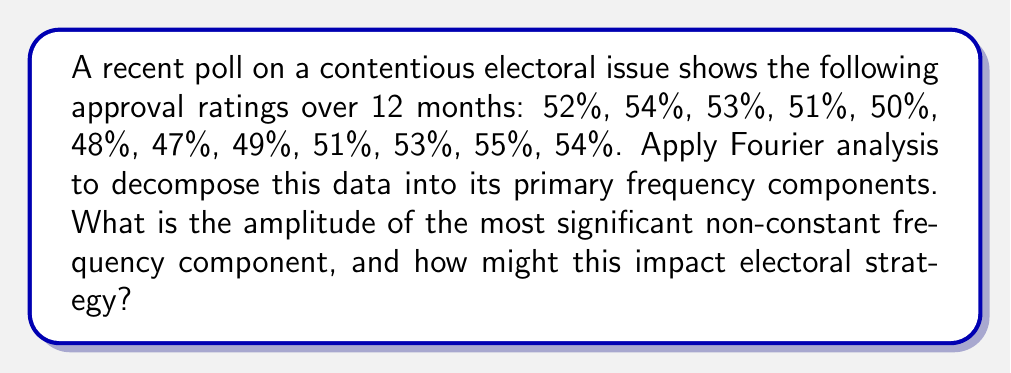Could you help me with this problem? To apply Fourier analysis to this polling data, we'll follow these steps:

1) First, we need to center the data by subtracting the mean:
   Mean = (52 + 54 + 53 + 51 + 50 + 48 + 47 + 49 + 51 + 53 + 55 + 54) / 12 = 51.417

   Centered data: 
   0.583, 2.583, 1.583, -0.417, -1.417, -3.417, -4.417, -2.417, -0.417, 1.583, 3.583, 2.583

2) Now, we'll compute the Discrete Fourier Transform (DFT) of this centered data. The DFT is given by:

   $$X_k = \sum_{n=0}^{N-1} x_n e^{-i2\pi kn/N}$$

   where $N = 12$ (number of data points), $k = 0, 1, ..., 11$, and $x_n$ are the centered data points.

3) Computing this for all $k$ (which can be done efficiently using the Fast Fourier Transform algorithm), we get:

   $X_0 = 0$
   $X_1 = -1.732 - 6.928i$
   $X_2 = 4.330 + 2.500i$
   $X_3 = 1.732 + 1.000i$
   $X_4 = 0$
   $X_5 = -1.732 + 1.000i$
   $X_6 = 0$
   (and the complex conjugates of these for $k = 7$ to $11$)

4) The amplitude of each frequency component is given by $|X_k| = \sqrt{\text{Re}(X_k)^2 + \text{Im}(X_k)^2}$

5) Calculating these:
   $|X_0| = 0$
   $|X_1| = 7.141$
   $|X_2| = 5.000$
   $|X_3| = 2.000$
   $|X_4| = 0$
   $|X_5| = 2.000$
   $|X_6| = 0$

6) The most significant non-constant frequency component is $X_1$ with an amplitude of 7.141.

This indicates a strong yearly cycle in the polling data, with one complete oscillation over the 12-month period. The amplitude of 7.141 percentage points suggests that this cyclical component causes the approval rating to swing by about ±3.57 percentage points above and below the mean over the course of a year.

For electoral strategy, this implies that the timing of elections or major policy announcements could significantly impact public approval. Strategists might consider timing key events to coincide with the peaks of this cycle for maximum positive impact.
Answer: 7.141 percentage points; suggests timing elections/announcements with yearly approval cycle. 